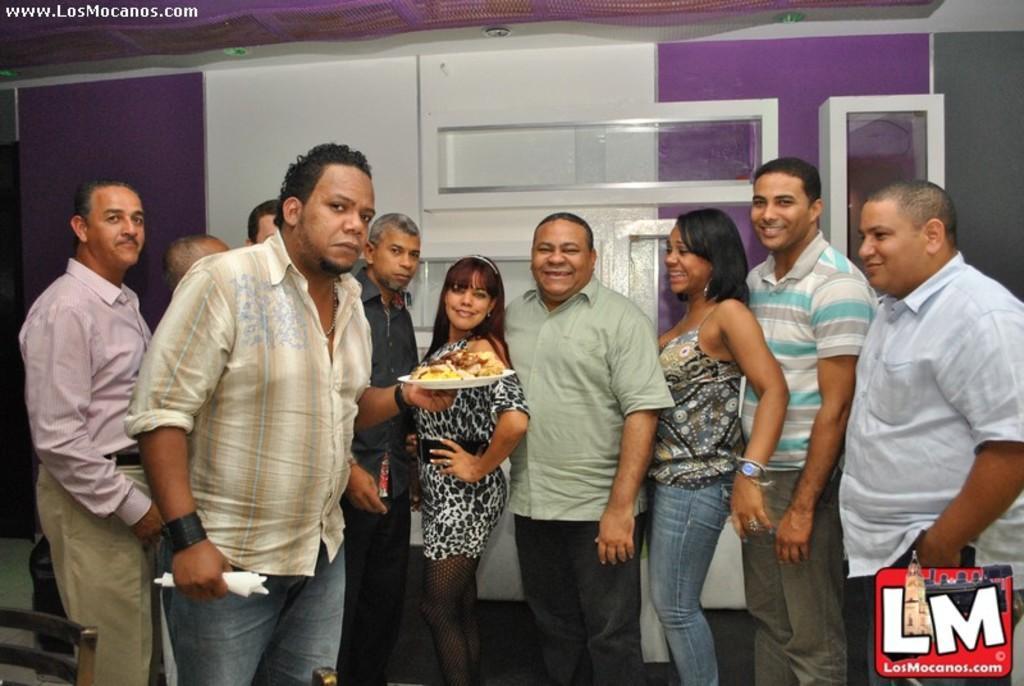Can you describe this image briefly? This picture shows few people standing with a smile on the faces and we see a man holding some food in the plate and napkins in another hand and we see text on the left top corner and a logo on the right bottom corner. 